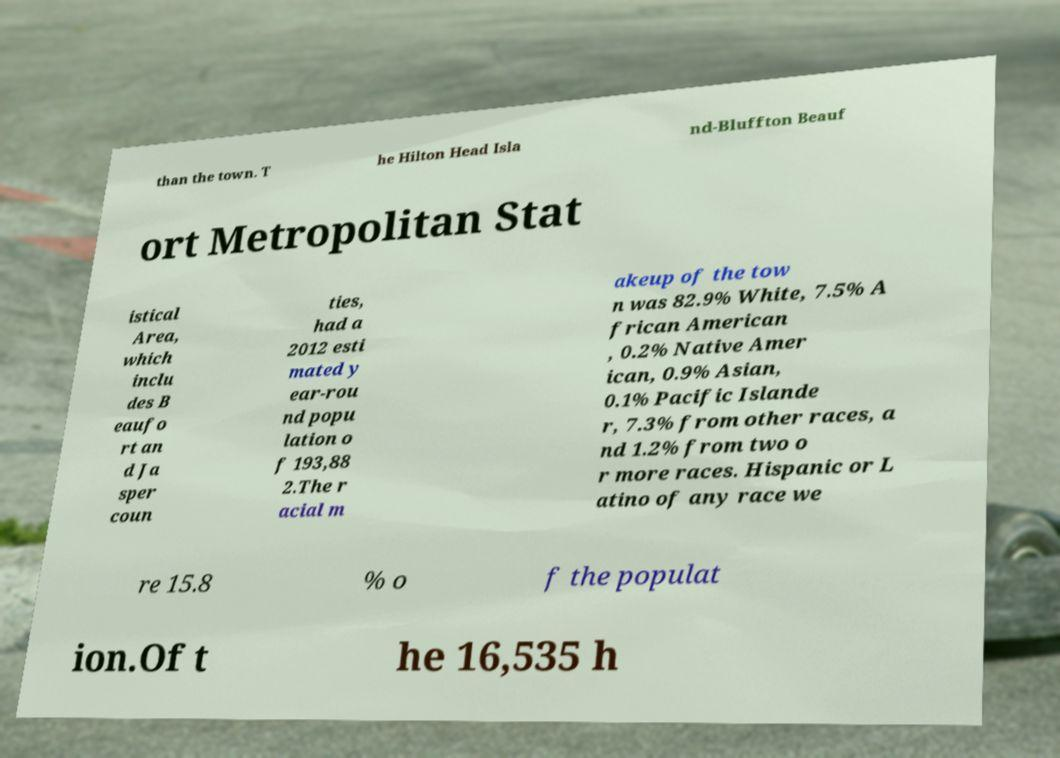What messages or text are displayed in this image? I need them in a readable, typed format. than the town. T he Hilton Head Isla nd-Bluffton Beauf ort Metropolitan Stat istical Area, which inclu des B eaufo rt an d Ja sper coun ties, had a 2012 esti mated y ear-rou nd popu lation o f 193,88 2.The r acial m akeup of the tow n was 82.9% White, 7.5% A frican American , 0.2% Native Amer ican, 0.9% Asian, 0.1% Pacific Islande r, 7.3% from other races, a nd 1.2% from two o r more races. Hispanic or L atino of any race we re 15.8 % o f the populat ion.Of t he 16,535 h 